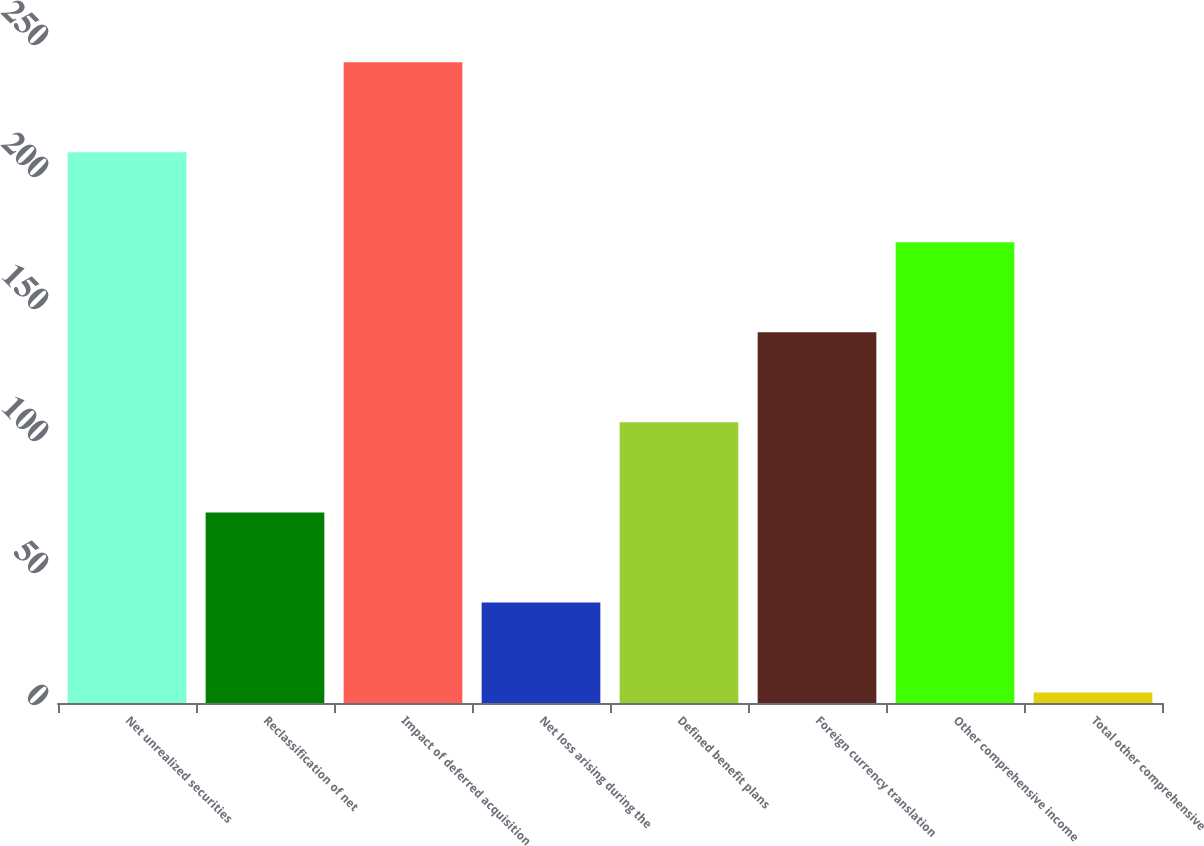Convert chart. <chart><loc_0><loc_0><loc_500><loc_500><bar_chart><fcel>Net unrealized securities<fcel>Reclassification of net<fcel>Impact of deferred acquisition<fcel>Net loss arising during the<fcel>Defined benefit plans<fcel>Foreign currency translation<fcel>Other comprehensive income<fcel>Total other comprehensive<nl><fcel>208.6<fcel>72.2<fcel>242.7<fcel>38.1<fcel>106.3<fcel>140.4<fcel>174.5<fcel>4<nl></chart> 